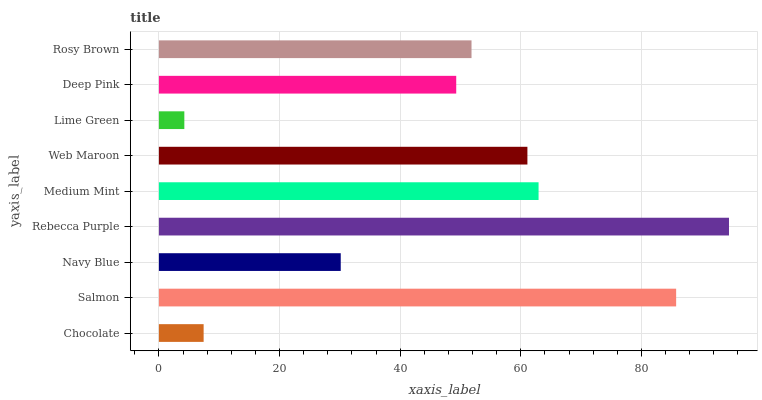Is Lime Green the minimum?
Answer yes or no. Yes. Is Rebecca Purple the maximum?
Answer yes or no. Yes. Is Salmon the minimum?
Answer yes or no. No. Is Salmon the maximum?
Answer yes or no. No. Is Salmon greater than Chocolate?
Answer yes or no. Yes. Is Chocolate less than Salmon?
Answer yes or no. Yes. Is Chocolate greater than Salmon?
Answer yes or no. No. Is Salmon less than Chocolate?
Answer yes or no. No. Is Rosy Brown the high median?
Answer yes or no. Yes. Is Rosy Brown the low median?
Answer yes or no. Yes. Is Rebecca Purple the high median?
Answer yes or no. No. Is Lime Green the low median?
Answer yes or no. No. 